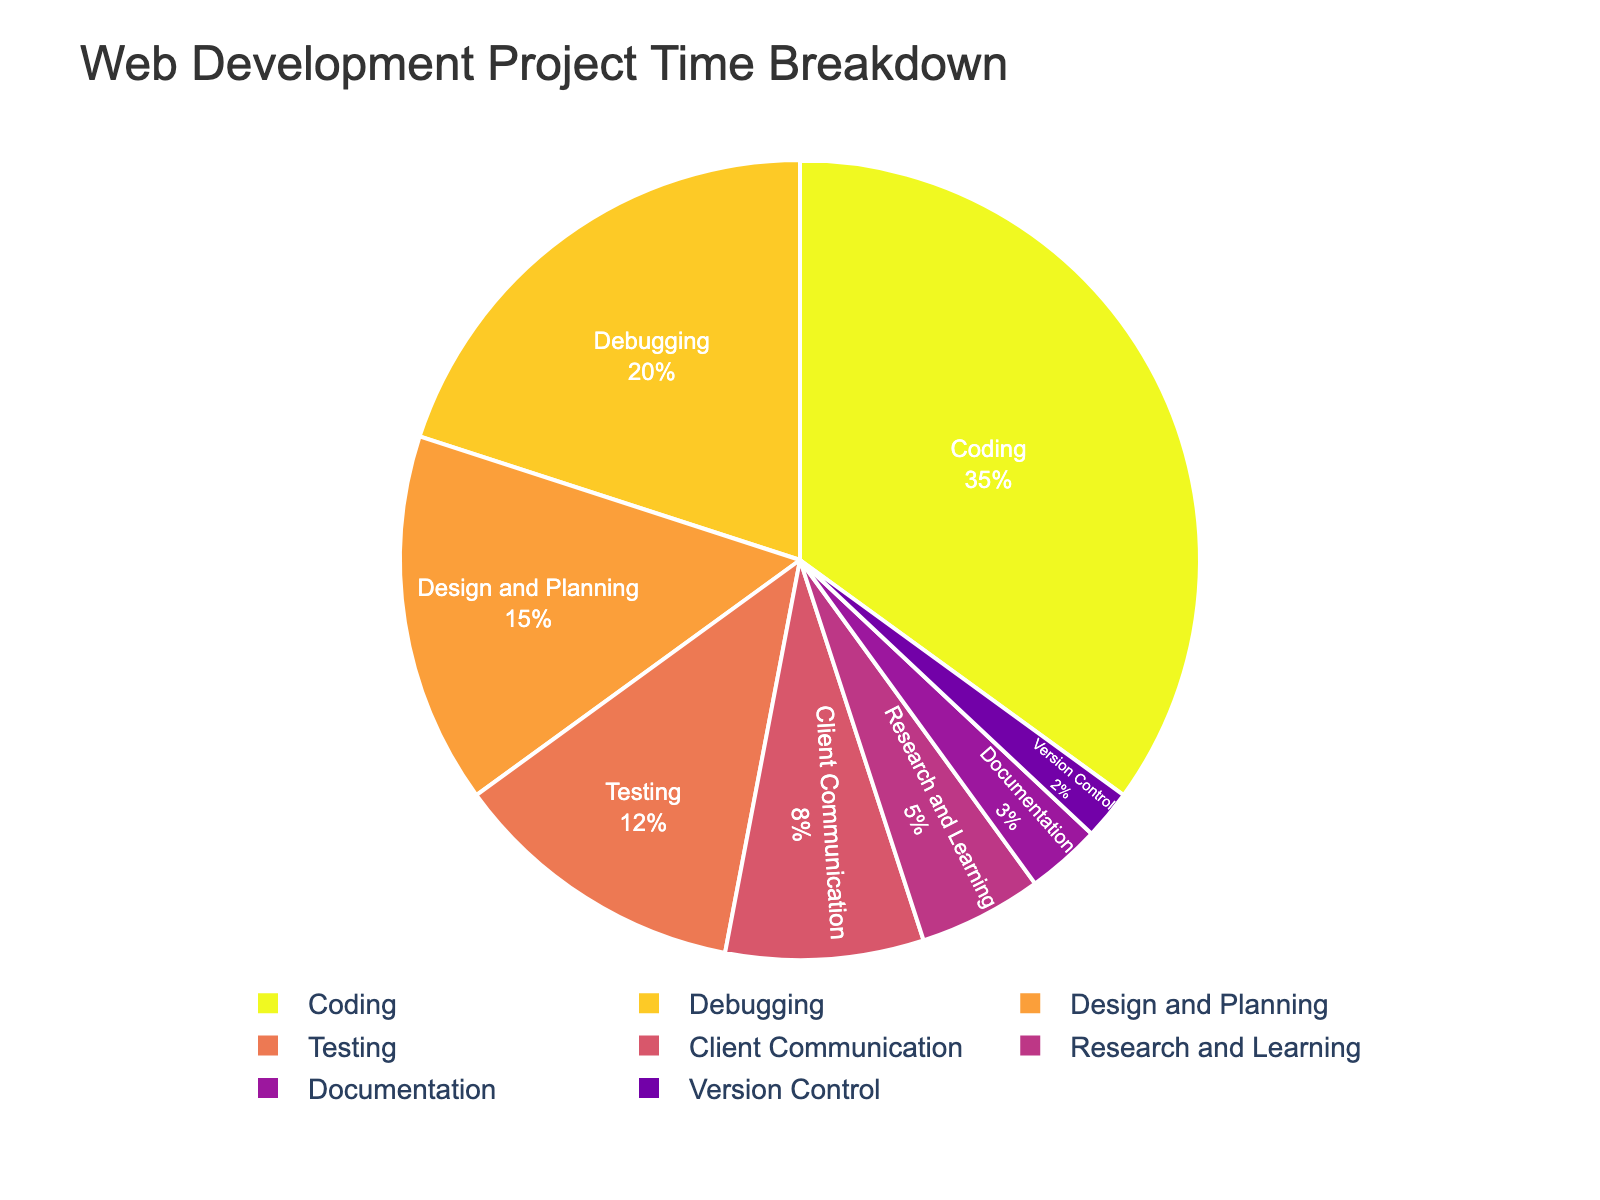what is the total percentage of time spent on Testing and Debugging phases? The Testing phase accounts for 12% and Debugging phase accounts for 20%. Adding these values gives 12 + 20 = 32%
Answer: 32% Which phase consumes the second largest portion of time? The phases and their corresponding percentages show Coding has the highest (35%), followed by Debugging with 20% and then Design and Planning with 15%. The second largest is Debugging at 20%
Answer: Debugging How does the combined percentage of Research and Learning, and Documentation compare to the percentage of Design and Planning? Research and Learning is 5% and Documentation is 3%. Their sum is 5 + 3 = 8%. Design and Planning is 15%. Comparing them, 8% is less than 15%
Answer: Less than Which phases take up the smallest and largest chunks of time respectively? The largest chunk is Coding with 35%, and the smallest chunk is Version Control with 2%
Answer: Version Control and Coding What is the difference in the percentage of time spent on Coding and Client Communication? Coding is 35% and Client Communication is 8%. The difference is 35 - 8 = 27%
Answer: 27% What percent of the project time is spent on phases that involve testing and debugging activities? Testing is 12% and Debugging is 20%, their sum is 12 + 20 = 32%
Answer: 32% Is the time spent on Design and Planning more than Research and Learning, Documentation, and Version Control combined? Design and Planning is 15%. Research and Learning is 5%, Documentation is 3%, and Version Control is 2%. Their sum is 5 + 3 + 2 = 10%. Design and Planning is more at 15%
Answer: Yes, more What proportion of the time is spent on client-related activities compared to coding? Client Communication is 8% and Coding is 35%. The proportion is 8 / 35 = 8/35 but simplified as approximately 0.23
Answer: 0.23 Compare and find the sum of time spent on Client Communication and Research and Learning. Is it greater than Debugging? Client Communication is 8%, Research and Learning is 5%, their sum is 8 + 5 = 13%. Debugging is 20%. The combined time, 13%, is less than Debugging at 20%
Answer: Less than How much more time is allocated to Debugging than Documentation? Debugging is 20% and Documentation is 3%. The difference is 20 - 3 = 17%
Answer: 17% 